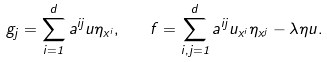Convert formula to latex. <formula><loc_0><loc_0><loc_500><loc_500>g _ { j } = \sum _ { i = 1 } ^ { d } a ^ { i j } u \eta _ { x ^ { i } } , \quad f = \sum _ { i , j = 1 } ^ { d } a ^ { i j } u _ { x ^ { i } } \eta _ { x ^ { j } } - \lambda \eta u .</formula> 